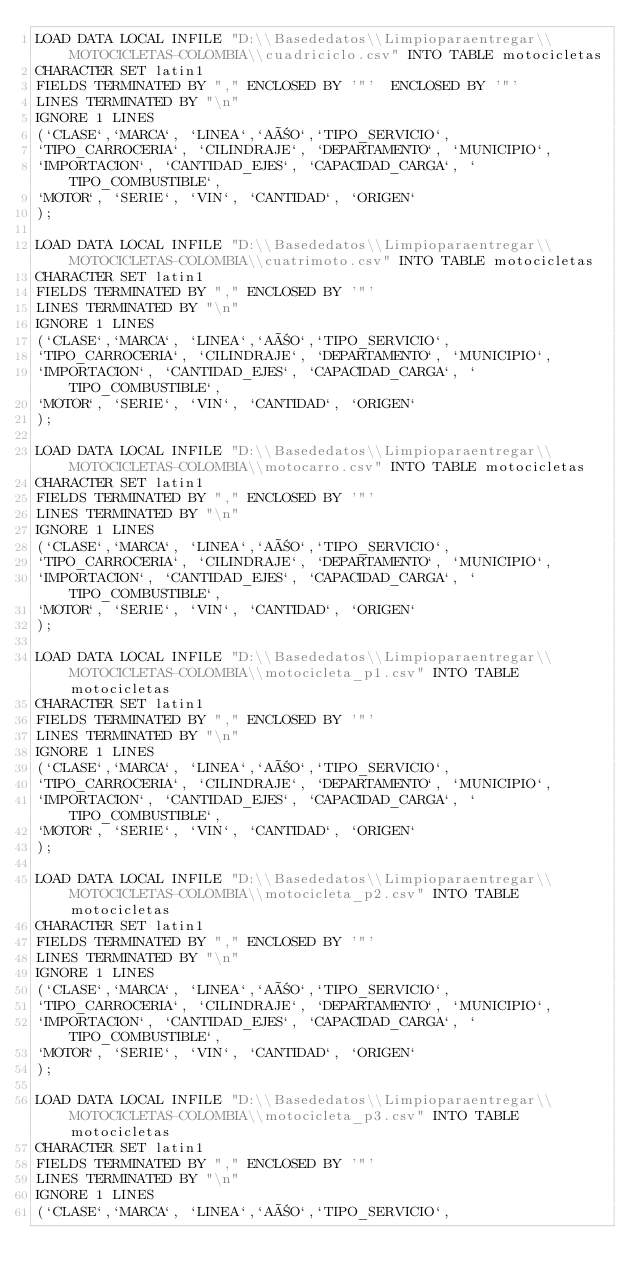<code> <loc_0><loc_0><loc_500><loc_500><_SQL_>LOAD DATA LOCAL INFILE "D:\\Basededatos\\Limpioparaentregar\\MOTOCICLETAS-COLOMBIA\\cuadriciclo.csv" INTO TABLE motocicletas
CHARACTER SET latin1
FIELDS TERMINATED BY "," ENCLOSED BY '"'  ENCLOSED BY '"' 
LINES TERMINATED BY "\n"
IGNORE 1 LINES
(`CLASE`,`MARCA`, `LINEA`,`AÑO`,`TIPO_SERVICIO`,
`TIPO_CARROCERIA`, `CILINDRAJE`, `DEPARTAMENTO`, `MUNICIPIO`,
`IMPORTACION`, `CANTIDAD_EJES`, `CAPACIDAD_CARGA`, `TIPO_COMBUSTIBLE`,
`MOTOR`, `SERIE`, `VIN`, `CANTIDAD`, `ORIGEN`
);

LOAD DATA LOCAL INFILE "D:\\Basededatos\\Limpioparaentregar\\MOTOCICLETAS-COLOMBIA\\cuatrimoto.csv" INTO TABLE motocicletas
CHARACTER SET latin1
FIELDS TERMINATED BY "," ENCLOSED BY '"' 
LINES TERMINATED BY "\n"
IGNORE 1 LINES
(`CLASE`,`MARCA`, `LINEA`,`AÑO`,`TIPO_SERVICIO`,
`TIPO_CARROCERIA`, `CILINDRAJE`, `DEPARTAMENTO`, `MUNICIPIO`,
`IMPORTACION`, `CANTIDAD_EJES`, `CAPACIDAD_CARGA`, `TIPO_COMBUSTIBLE`,
`MOTOR`, `SERIE`, `VIN`, `CANTIDAD`, `ORIGEN`
);

LOAD DATA LOCAL INFILE "D:\\Basededatos\\Limpioparaentregar\\MOTOCICLETAS-COLOMBIA\\motocarro.csv" INTO TABLE motocicletas
CHARACTER SET latin1
FIELDS TERMINATED BY "," ENCLOSED BY '"' 
LINES TERMINATED BY "\n"
IGNORE 1 LINES
(`CLASE`,`MARCA`, `LINEA`,`AÑO`,`TIPO_SERVICIO`,
`TIPO_CARROCERIA`, `CILINDRAJE`, `DEPARTAMENTO`, `MUNICIPIO`,
`IMPORTACION`, `CANTIDAD_EJES`, `CAPACIDAD_CARGA`, `TIPO_COMBUSTIBLE`,
`MOTOR`, `SERIE`, `VIN`, `CANTIDAD`, `ORIGEN`
);

LOAD DATA LOCAL INFILE "D:\\Basededatos\\Limpioparaentregar\\MOTOCICLETAS-COLOMBIA\\motocicleta_p1.csv" INTO TABLE motocicletas
CHARACTER SET latin1
FIELDS TERMINATED BY "," ENCLOSED BY '"' 
LINES TERMINATED BY "\n"
IGNORE 1 LINES
(`CLASE`,`MARCA`, `LINEA`,`AÑO`,`TIPO_SERVICIO`,
`TIPO_CARROCERIA`, `CILINDRAJE`, `DEPARTAMENTO`, `MUNICIPIO`,
`IMPORTACION`, `CANTIDAD_EJES`, `CAPACIDAD_CARGA`, `TIPO_COMBUSTIBLE`,
`MOTOR`, `SERIE`, `VIN`, `CANTIDAD`, `ORIGEN`
);

LOAD DATA LOCAL INFILE "D:\\Basededatos\\Limpioparaentregar\\MOTOCICLETAS-COLOMBIA\\motocicleta_p2.csv" INTO TABLE motocicletas
CHARACTER SET latin1
FIELDS TERMINATED BY "," ENCLOSED BY '"' 
LINES TERMINATED BY "\n"
IGNORE 1 LINES
(`CLASE`,`MARCA`, `LINEA`,`AÑO`,`TIPO_SERVICIO`,
`TIPO_CARROCERIA`, `CILINDRAJE`, `DEPARTAMENTO`, `MUNICIPIO`,
`IMPORTACION`, `CANTIDAD_EJES`, `CAPACIDAD_CARGA`, `TIPO_COMBUSTIBLE`,
`MOTOR`, `SERIE`, `VIN`, `CANTIDAD`, `ORIGEN`
);

LOAD DATA LOCAL INFILE "D:\\Basededatos\\Limpioparaentregar\\MOTOCICLETAS-COLOMBIA\\motocicleta_p3.csv" INTO TABLE motocicletas
CHARACTER SET latin1
FIELDS TERMINATED BY "," ENCLOSED BY '"' 
LINES TERMINATED BY "\n"
IGNORE 1 LINES
(`CLASE`,`MARCA`, `LINEA`,`AÑO`,`TIPO_SERVICIO`,</code> 